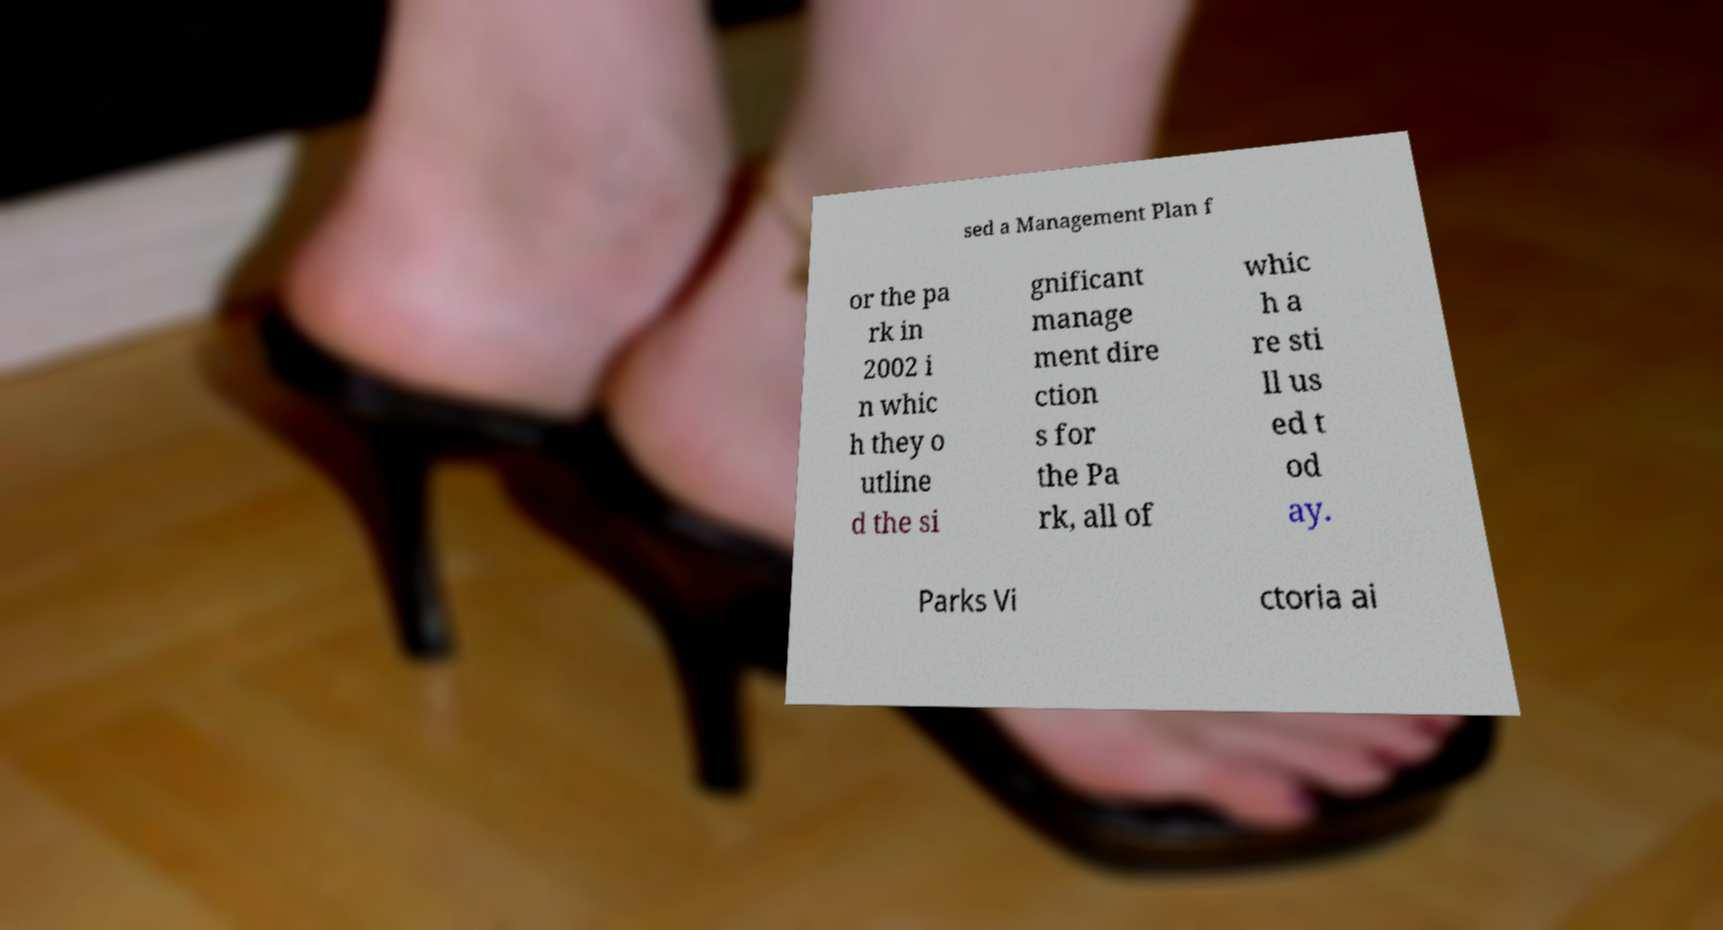Could you extract and type out the text from this image? sed a Management Plan f or the pa rk in 2002 i n whic h they o utline d the si gnificant manage ment dire ction s for the Pa rk, all of whic h a re sti ll us ed t od ay. Parks Vi ctoria ai 